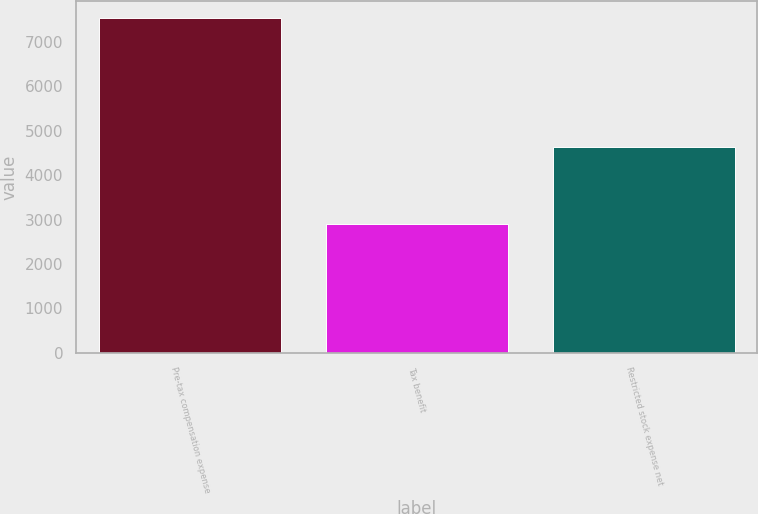Convert chart to OTSL. <chart><loc_0><loc_0><loc_500><loc_500><bar_chart><fcel>Pre-tax compensation expense<fcel>Tax benefit<fcel>Restricted stock expense net<nl><fcel>7538<fcel>2902<fcel>4636<nl></chart> 